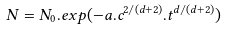<formula> <loc_0><loc_0><loc_500><loc_500>N = N _ { 0 } . e x p ( { - a . { c ^ { 2 / ( d + 2 ) } } . { t ^ { d / ( d + 2 ) } } } )</formula> 